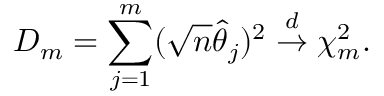Convert formula to latex. <formula><loc_0><loc_0><loc_500><loc_500>D _ { m } = \sum _ { j = 1 } ^ { m } ( \sqrt { n } \widehat { \theta } _ { j } ) ^ { 2 } \stackrel { d } { \rightarrow } \chi _ { m } ^ { 2 } .</formula> 